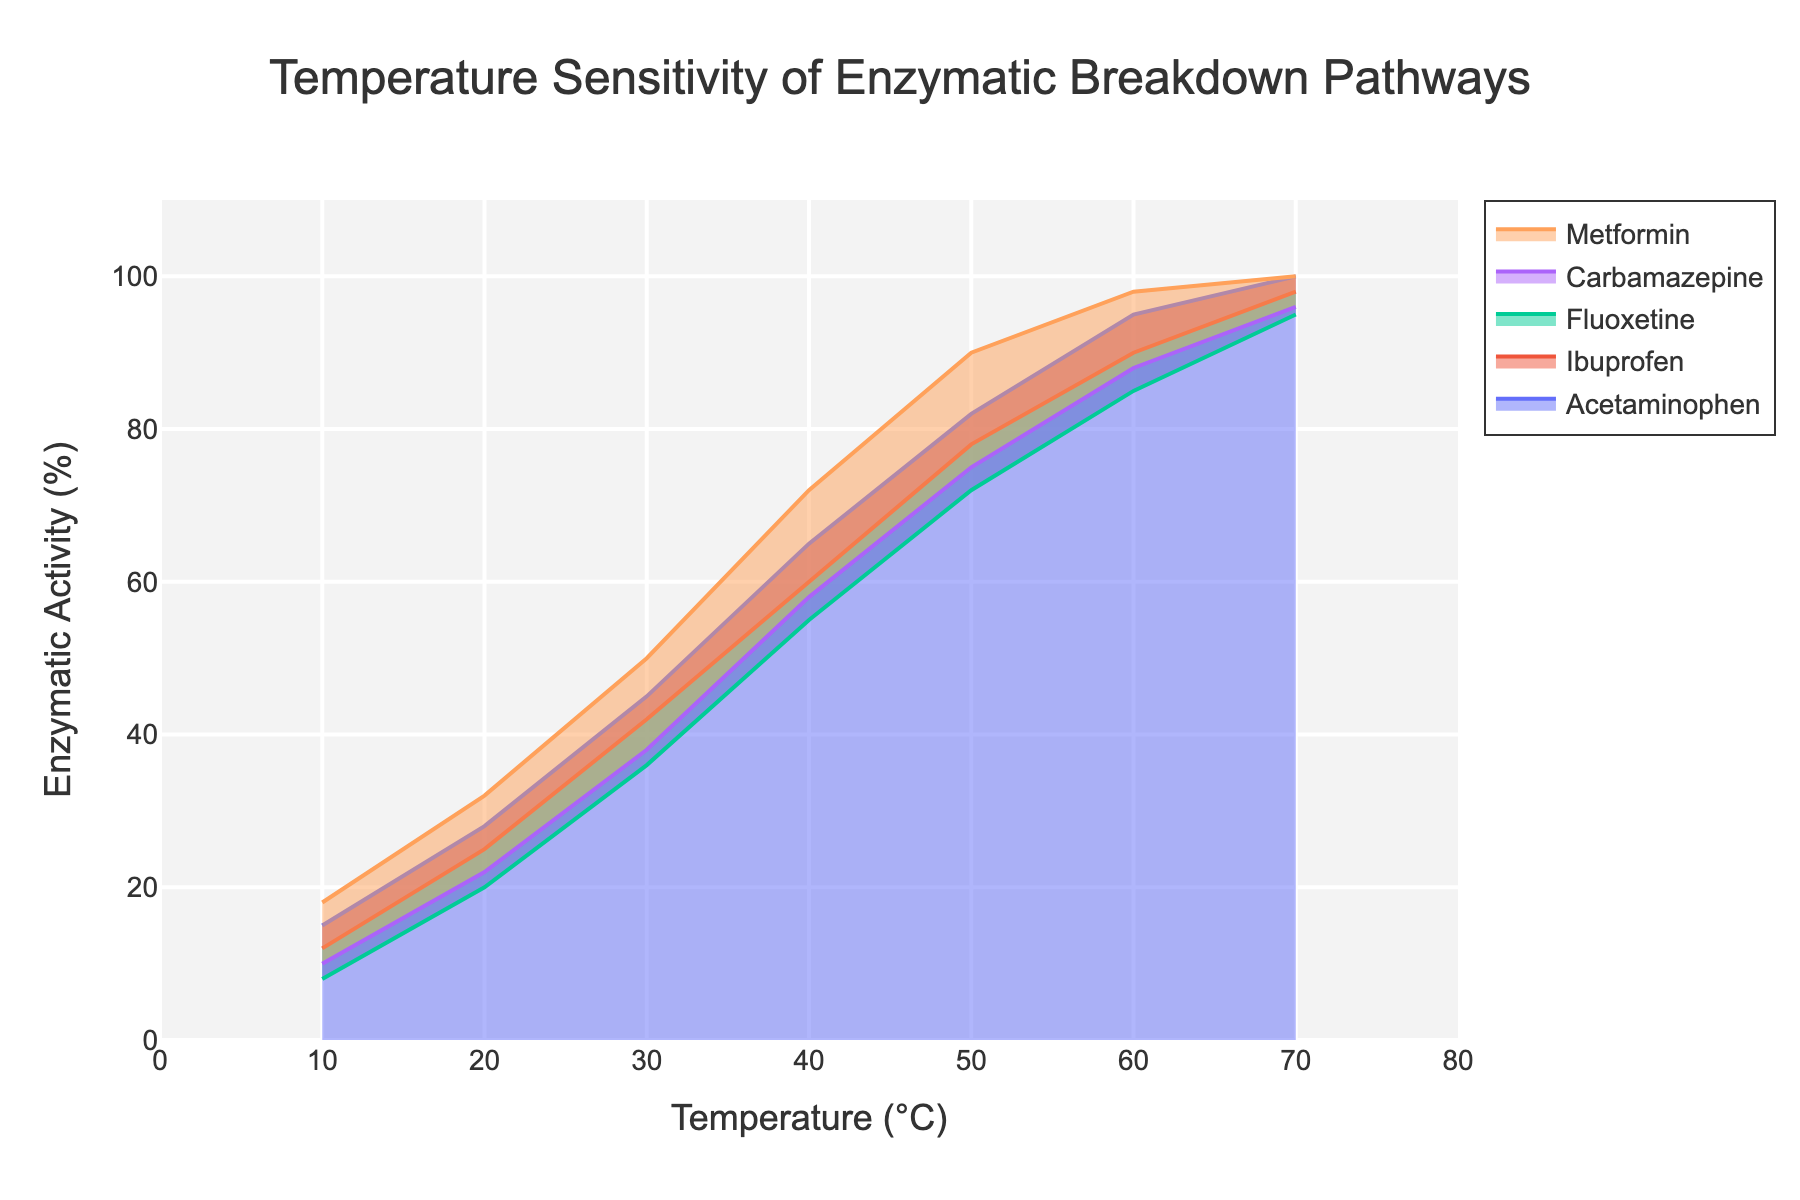What's the title of the figure? The title is usually displayed at the top of the chart in bold or larger font size. Here, it is located centrally and at the top.
Answer: Temperature Sensitivity of Enzymatic Breakdown Pathways What's the enzymatic activity percentage of Ibuprofen at 40°C? Locate the point on the x-axis corresponding to 40°C, then find where the Ibuprofen line intersects this point, and read the corresponding y-axis value.
Answer: 60% At which temperature does Metformin reach 100% enzymatic activity? Identify the line representing Metformin and locate the point where it reaches 100% on the y-axis, then read the corresponding x-axis value.
Answer: 70°C Which drug has the highest enzymatic activity at 30°C? Compare the y-axis values for all drugs at 30°C and identify the highest value.
Answer: Metformin How does the enzymatic activity of Carbamazepine change from 10°C to 50°C? Calculate the difference in the enzymatic activity of Carbamazepine between 10°C and 50°C.
Answer: 65% increase What's the average enzymatic activity of Acetaminophen between 20°C and 60°C? Calculate the average by summing the enzymatic activities of Acetaminophen at 20°C, 30°C, 40°C, 50°C, and 60°C and then dividing by 5.
Answer: 63% Is the enzymatic activity of Fluoxetine greater than that of Ibuprofen at 60°C? Compare the y-axis values of Fluoxetine and Ibuprofen at 60°C.
Answer: Yes How does the enzymatic activity of all drugs compare at 70°C? List the enzymatic activity values of all drugs at 70°C and compare them.
Answer: Acetaminophen: 100%, Ibuprofen: 98%, Fluoxetine: 95%, Carbamazepine: 96%, Metformin: 100% What's the general trend in enzymatic activity with increasing temperature for all drugs? Analyze the overall direction of the lines for all drugs from 10°C to 70°C.
Answer: Increase 